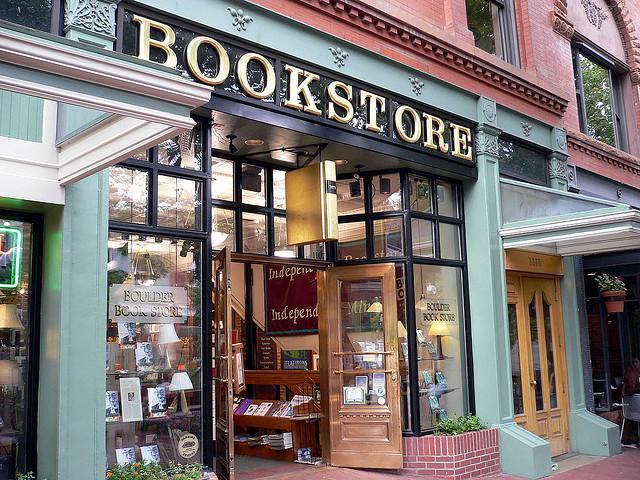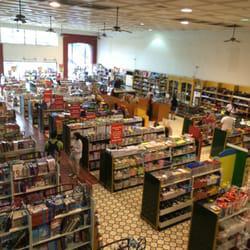The first image is the image on the left, the second image is the image on the right. Analyze the images presented: Is the assertion "There are at least two people in the image on the right." valid? Answer yes or no. Yes. 